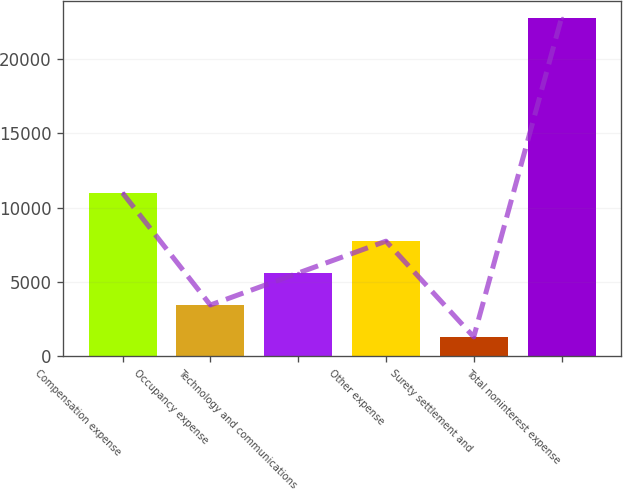Convert chart to OTSL. <chart><loc_0><loc_0><loc_500><loc_500><bar_chart><fcel>Compensation expense<fcel>Occupancy expense<fcel>Technology and communications<fcel>Other expense<fcel>Surety settlement and<fcel>Total noninterest expense<nl><fcel>10983<fcel>3446.4<fcel>5592.8<fcel>7739.2<fcel>1300<fcel>22764<nl></chart> 